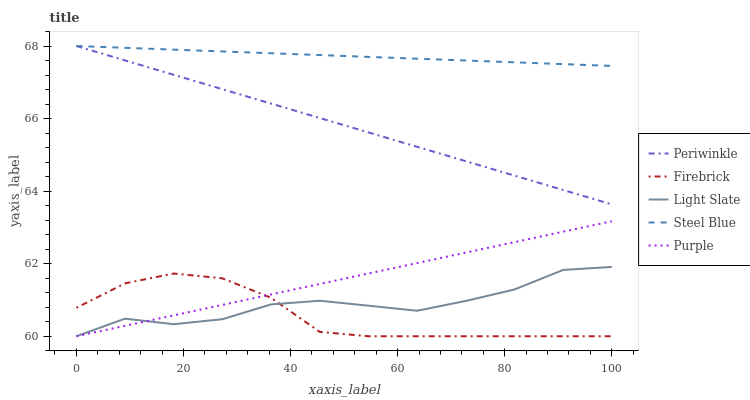Does Purple have the minimum area under the curve?
Answer yes or no. No. Does Purple have the maximum area under the curve?
Answer yes or no. No. Is Firebrick the smoothest?
Answer yes or no. No. Is Firebrick the roughest?
Answer yes or no. No. Does Periwinkle have the lowest value?
Answer yes or no. No. Does Purple have the highest value?
Answer yes or no. No. Is Firebrick less than Steel Blue?
Answer yes or no. Yes. Is Steel Blue greater than Light Slate?
Answer yes or no. Yes. Does Firebrick intersect Steel Blue?
Answer yes or no. No. 